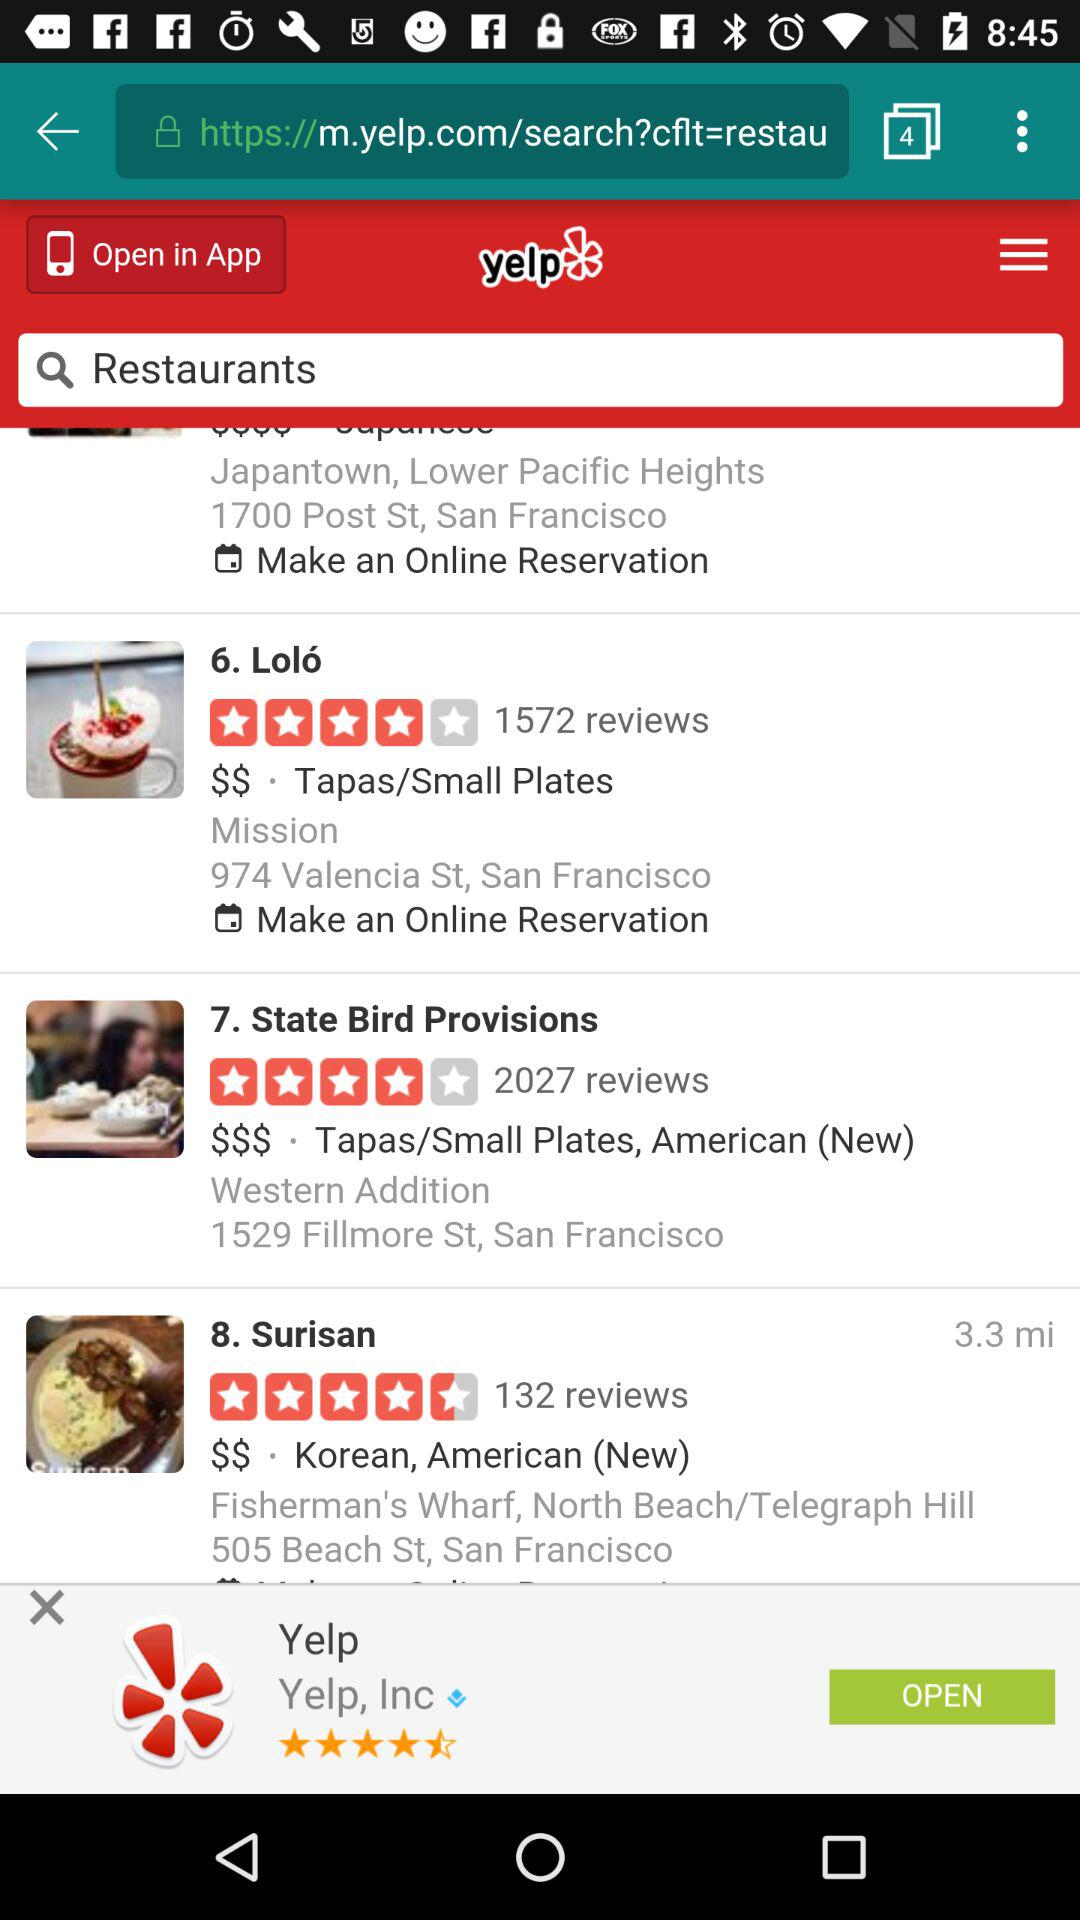What is the rating of the "State Bird Provisions"? The rating is 4 stars. 